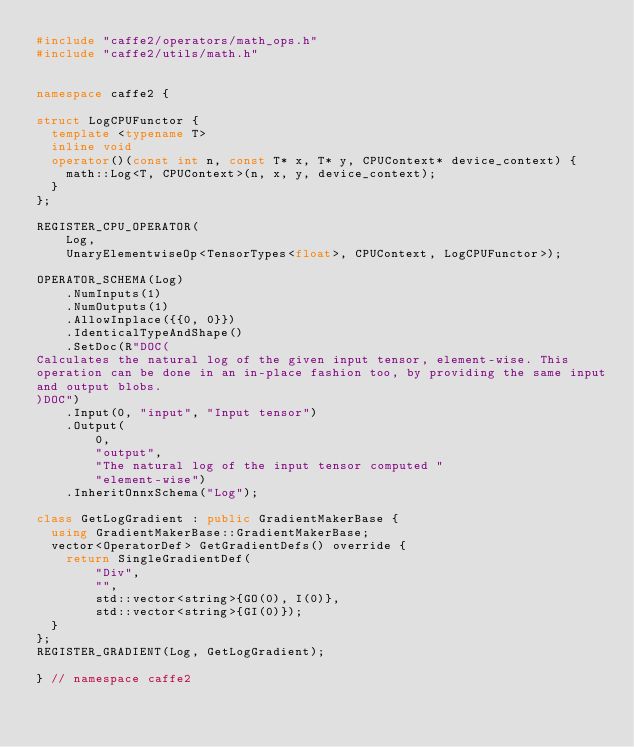Convert code to text. <code><loc_0><loc_0><loc_500><loc_500><_C++_>#include "caffe2/operators/math_ops.h"
#include "caffe2/utils/math.h"


namespace caffe2 {

struct LogCPUFunctor {
  template <typename T>
  inline void
  operator()(const int n, const T* x, T* y, CPUContext* device_context) {
    math::Log<T, CPUContext>(n, x, y, device_context);
  }
};

REGISTER_CPU_OPERATOR(
    Log,
    UnaryElementwiseOp<TensorTypes<float>, CPUContext, LogCPUFunctor>);

OPERATOR_SCHEMA(Log)
    .NumInputs(1)
    .NumOutputs(1)
    .AllowInplace({{0, 0}})
    .IdenticalTypeAndShape()
    .SetDoc(R"DOC(
Calculates the natural log of the given input tensor, element-wise. This
operation can be done in an in-place fashion too, by providing the same input
and output blobs.
)DOC")
    .Input(0, "input", "Input tensor")
    .Output(
        0,
        "output",
        "The natural log of the input tensor computed "
        "element-wise")
    .InheritOnnxSchema("Log");

class GetLogGradient : public GradientMakerBase {
  using GradientMakerBase::GradientMakerBase;
  vector<OperatorDef> GetGradientDefs() override {
    return SingleGradientDef(
        "Div",
        "",
        std::vector<string>{GO(0), I(0)},
        std::vector<string>{GI(0)});
  }
};
REGISTER_GRADIENT(Log, GetLogGradient);

} // namespace caffe2
</code> 